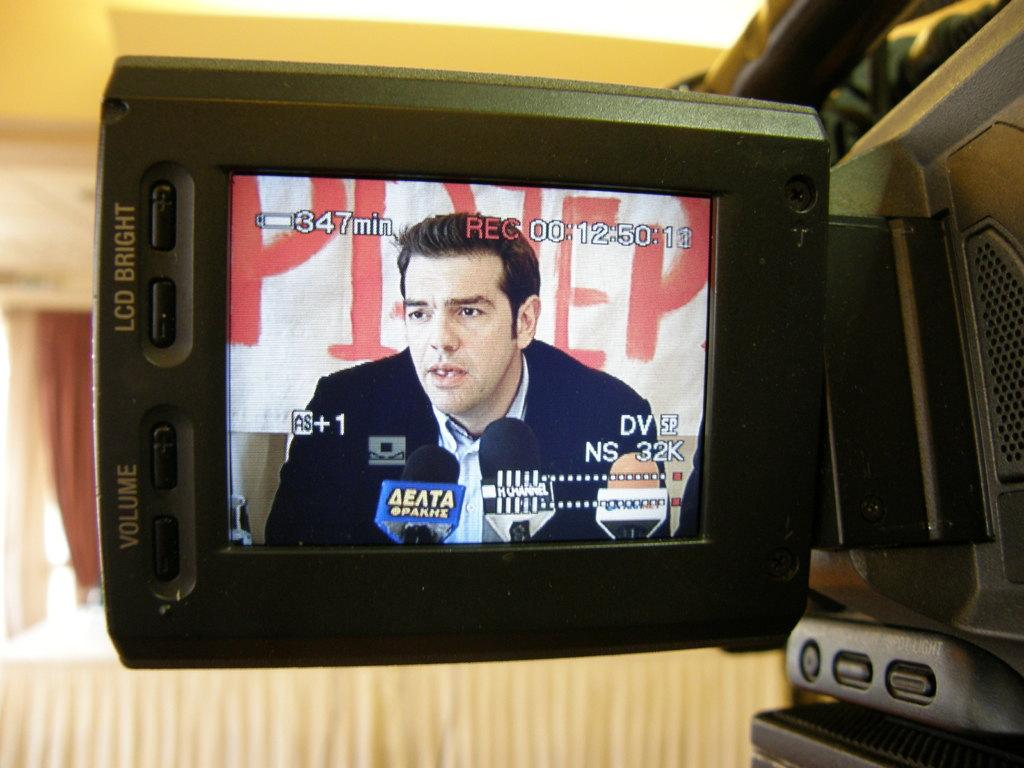<image>
Relay a brief, clear account of the picture shown. A man is being interviewed and it can be seen on a video recorder screen which has a red REC sign on the top of the screen. 